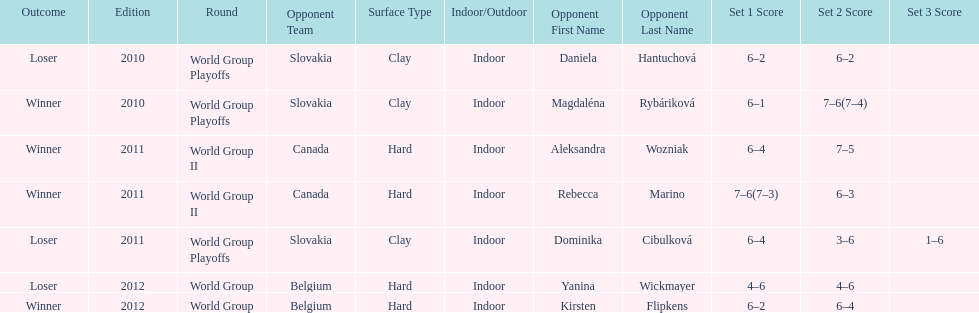Did they beat canada in more or less than 3 matches? Less. 